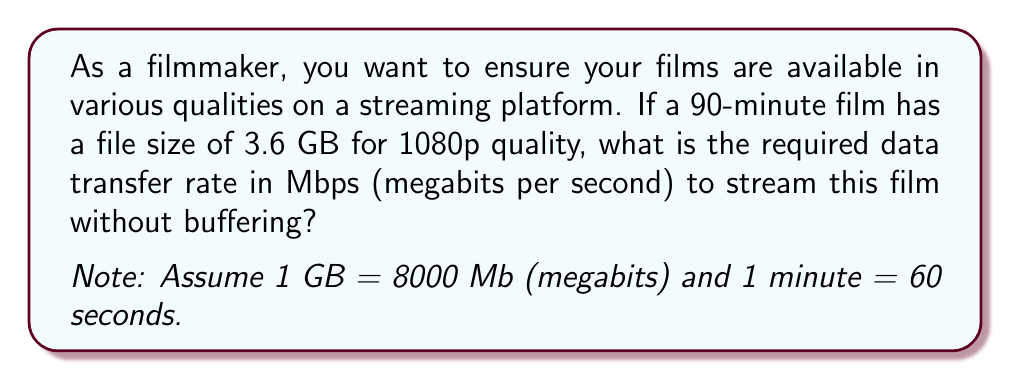Could you help me with this problem? To solve this problem, we'll follow these steps:

1. Convert the file size from GB to Mb:
   $3.6 \text{ GB} \times 8000 \text{ Mb/GB} = 28800 \text{ Mb}$

2. Convert the duration from minutes to seconds:
   $90 \text{ minutes} \times 60 \text{ seconds/minute} = 5400 \text{ seconds}$

3. Calculate the data transfer rate using the formula:
   $$\text{Data Transfer Rate} = \frac{\text{File Size}}{\text{Duration}}$$

   Substituting our values:
   $$\text{Data Transfer Rate} = \frac{28800 \text{ Mb}}{5400 \text{ seconds}}$$

4. Perform the division:
   $$\text{Data Transfer Rate} = 5.33333... \text{ Mbps}$$

5. Round to two decimal places for a practical answer:
   $$\text{Data Transfer Rate} \approx 5.33 \text{ Mbps}$$

This means that to stream the 1080p version of your 90-minute film without buffering, the streaming platform would need to provide a consistent data transfer rate of at least 5.33 Mbps.
Answer: $5.33 \text{ Mbps}$ 